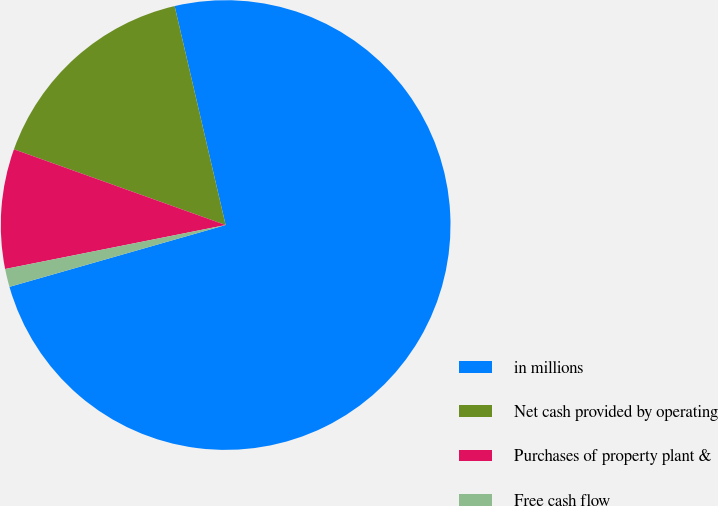Convert chart to OTSL. <chart><loc_0><loc_0><loc_500><loc_500><pie_chart><fcel>in millions<fcel>Net cash provided by operating<fcel>Purchases of property plant &<fcel>Free cash flow<nl><fcel>74.21%<fcel>15.89%<fcel>8.6%<fcel>1.3%<nl></chart> 